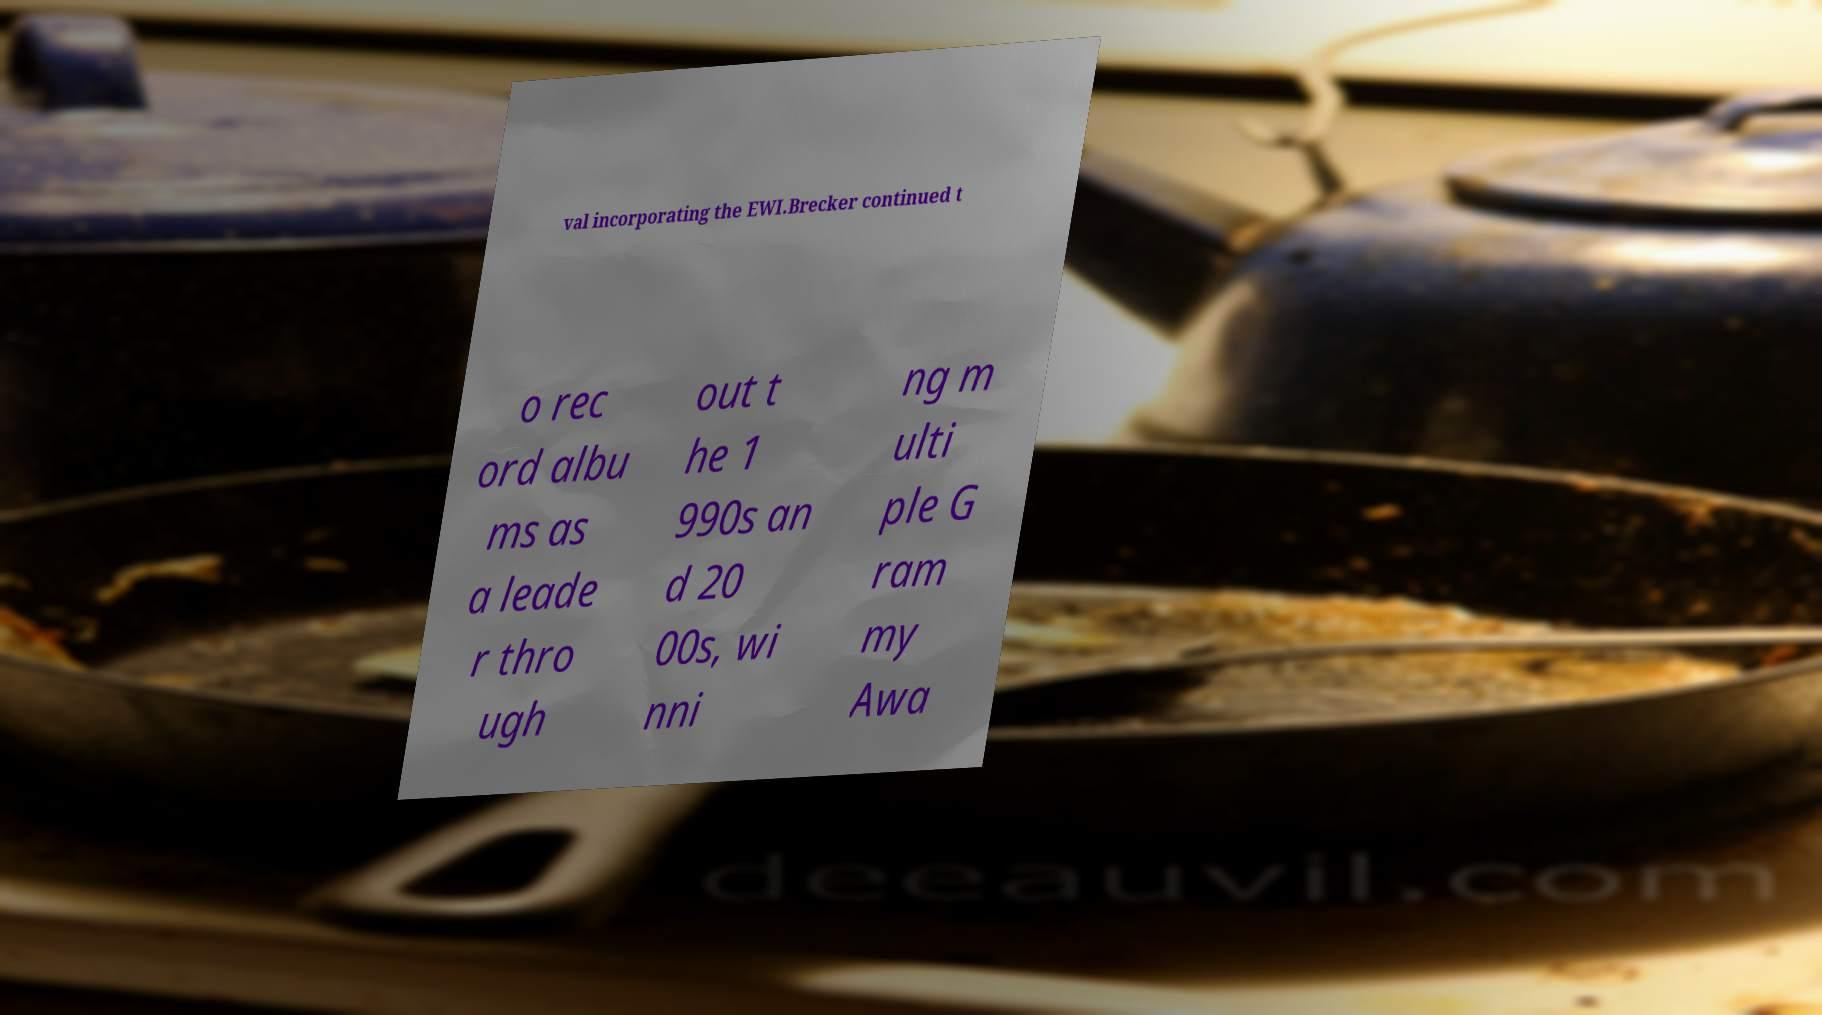Please read and relay the text visible in this image. What does it say? val incorporating the EWI.Brecker continued t o rec ord albu ms as a leade r thro ugh out t he 1 990s an d 20 00s, wi nni ng m ulti ple G ram my Awa 